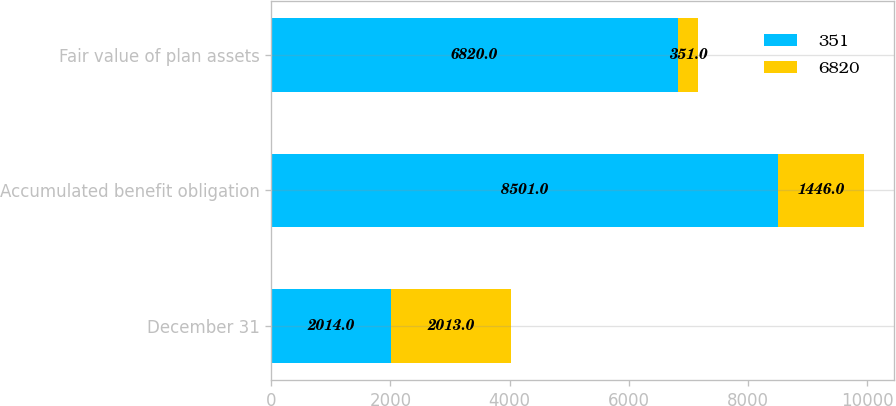Convert chart to OTSL. <chart><loc_0><loc_0><loc_500><loc_500><stacked_bar_chart><ecel><fcel>December 31<fcel>Accumulated benefit obligation<fcel>Fair value of plan assets<nl><fcel>351<fcel>2014<fcel>8501<fcel>6820<nl><fcel>6820<fcel>2013<fcel>1446<fcel>351<nl></chart> 